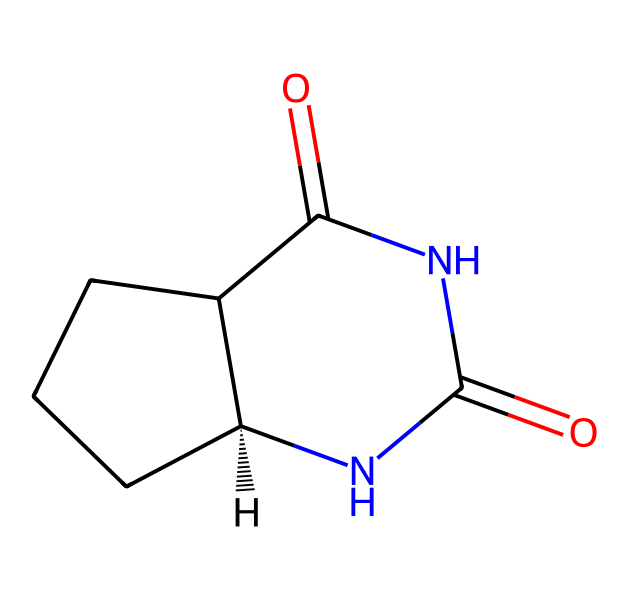How many chiral centers are in this molecule? By examining the structure, we can identify that there is one carbon atom that is bonded to four different substituents, which is defined as a chiral center.
Answer: one What are the functional groups present in this structure? The structure displays an amide functional group (due to the presence of carbonyl adjacent to a nitrogen) and a cyclic structure indicating a lactam (cyclic amide), which are common in drugs.
Answer: amide, lactam What is the total number of nitrogen atoms in the molecule? Looking at the chemical structure, we can count that there are two nitrogen atoms present within the amide groups of the molecule.
Answer: two Which enantiomeric form is represented by the given SMILES notation? The notation includes the "@H" symbol indicating the stereochemistry of the chiral center, which signifies the specific orientation of the enantiomer, specifically the S or R configuration based on priority rules.
Answer: S How does chirality potentially affect the drug's pharmacological activity? Chirality can influence the drug's interaction with biological systems, where one enantiomer may be therapeutically active while the other may be inactive or even harmful, due to differences in binding to biological receptors.
Answer: therapeutic activity What type of drug can this molecule be categorized as? Considering the presence of an amide and cyclic structures commonly found in pharmaceuticals, and the specific types of bonding, this molecule can be categorized as a heterocyclic compound, particularly an antibiotic or similar bioactive substance.
Answer: heterocyclic compound, antibiotic 